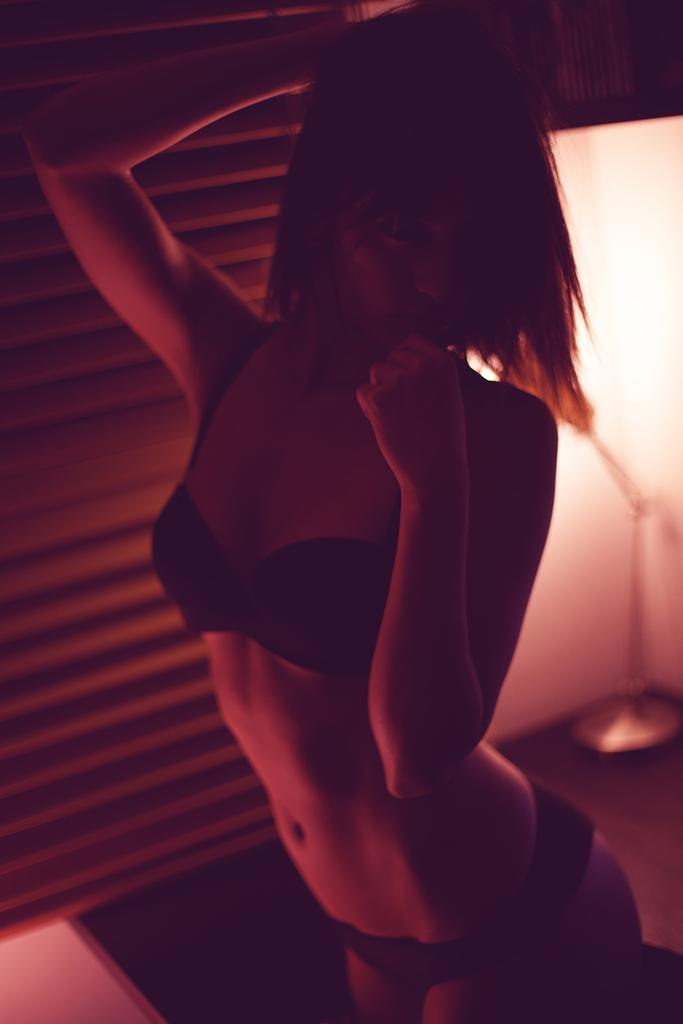Who is the main subject in the image? There is a girl in the image. Where is the girl located in the image? The girl is in the middle of the image. What object can be seen on the right side of the image? There is a metal rod on the right side of the image. What type of advertisement is the girl holding in the image? There is no advertisement present in the image. What type of business does the girl represent in the image? There is no indication of a business or representation in the image. 